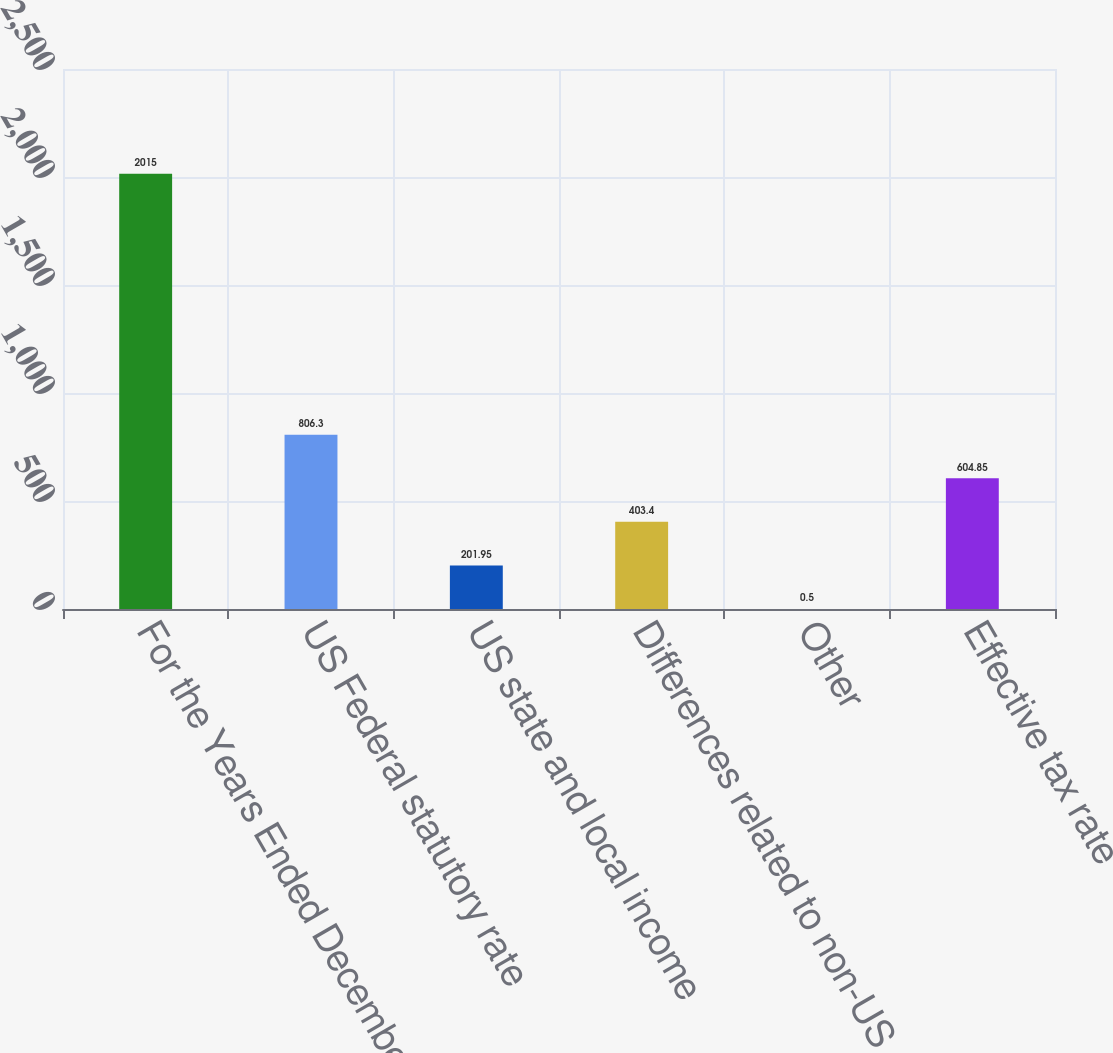<chart> <loc_0><loc_0><loc_500><loc_500><bar_chart><fcel>For the Years Ended December<fcel>US Federal statutory rate<fcel>US state and local income<fcel>Differences related to non-US<fcel>Other<fcel>Effective tax rate<nl><fcel>2015<fcel>806.3<fcel>201.95<fcel>403.4<fcel>0.5<fcel>604.85<nl></chart> 